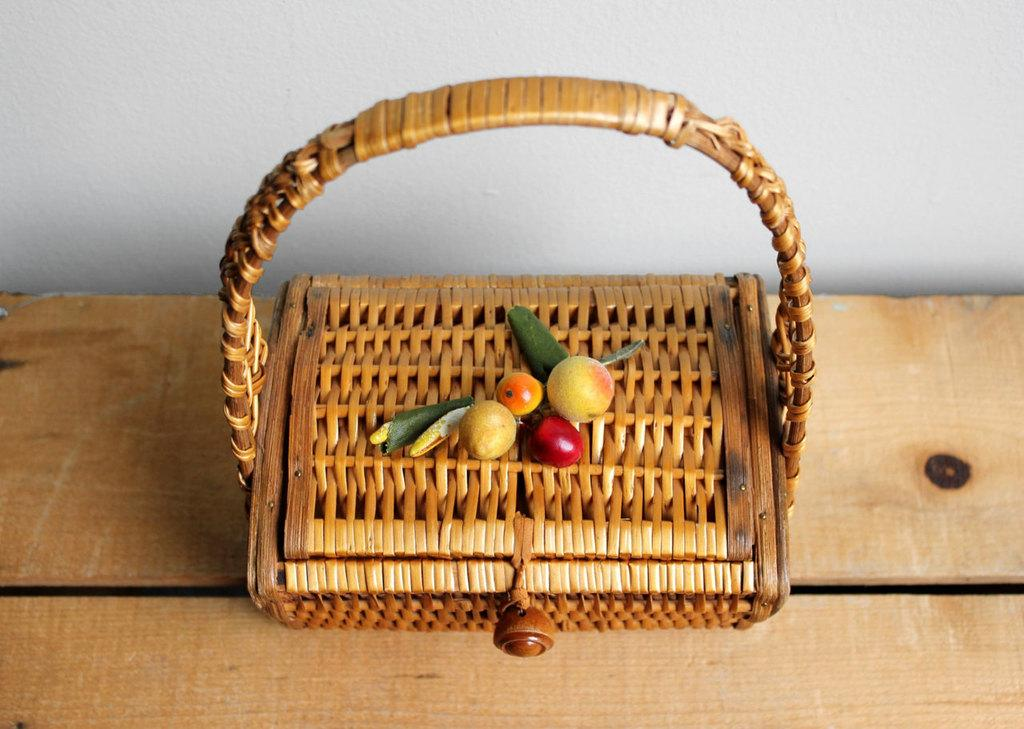What object is present in the image that can hold items? There is a basket in the image that can hold items. Where is the basket located in the image? The basket is placed on a wooden surface. What type of food can be seen in the image? There are fruits in the image. How many notebooks are stacked on the wooden surface next to the basket? There are no notebooks present in the image; only a basket and fruits can be seen. 